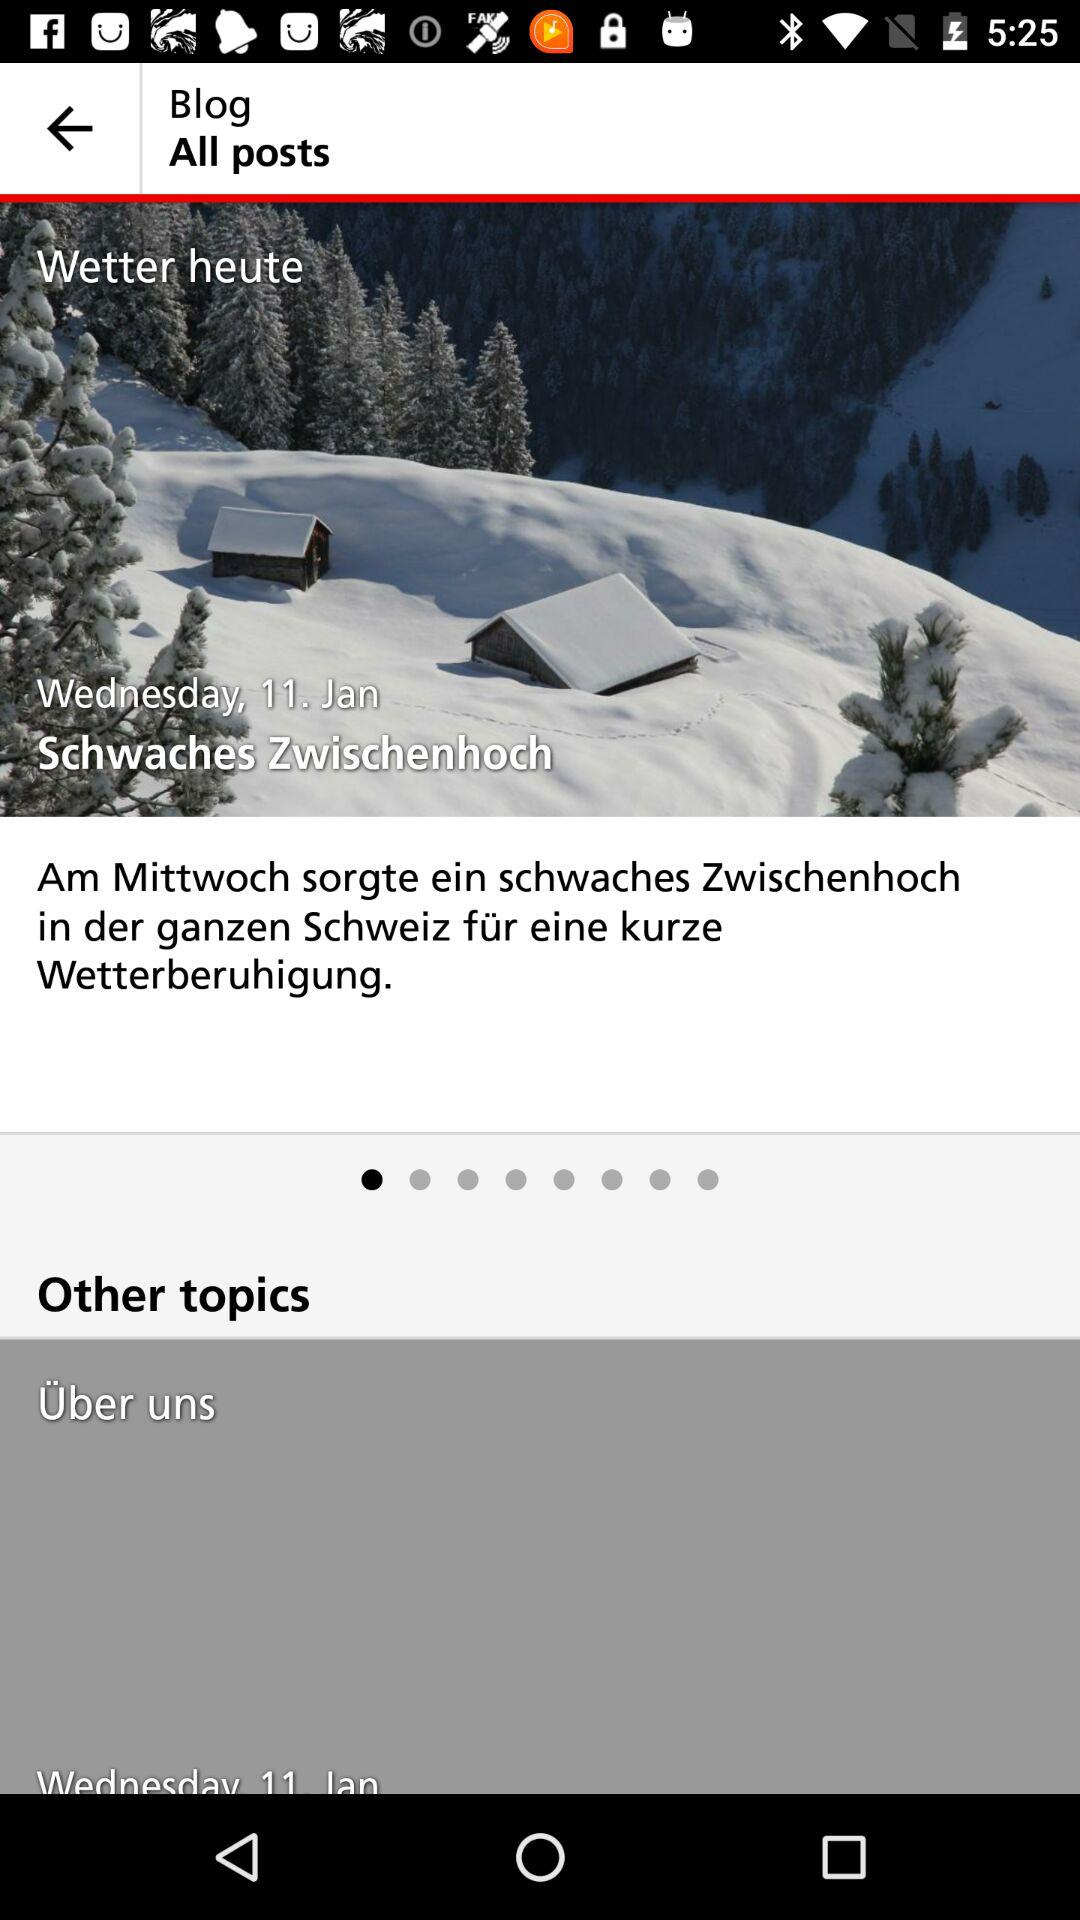What day falls on 11th January? The day is Wednesday. 